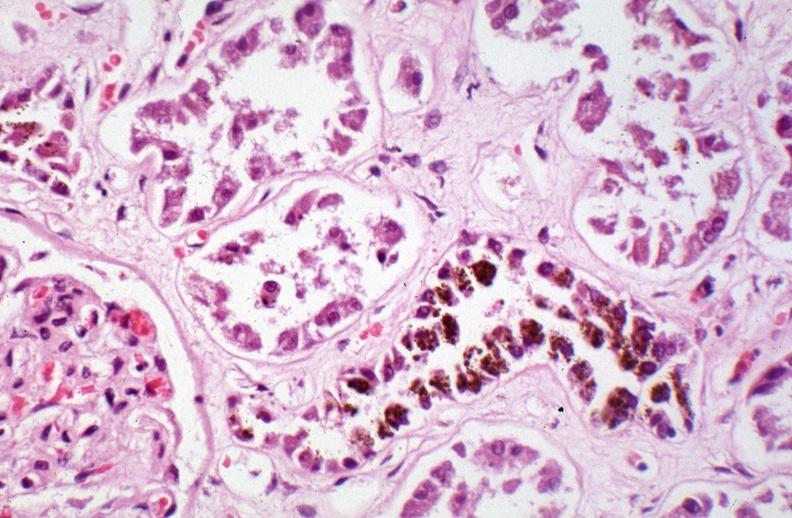how is hemosiderosis caused?
Answer the question using a single word or phrase. Numerous blood transfusions 